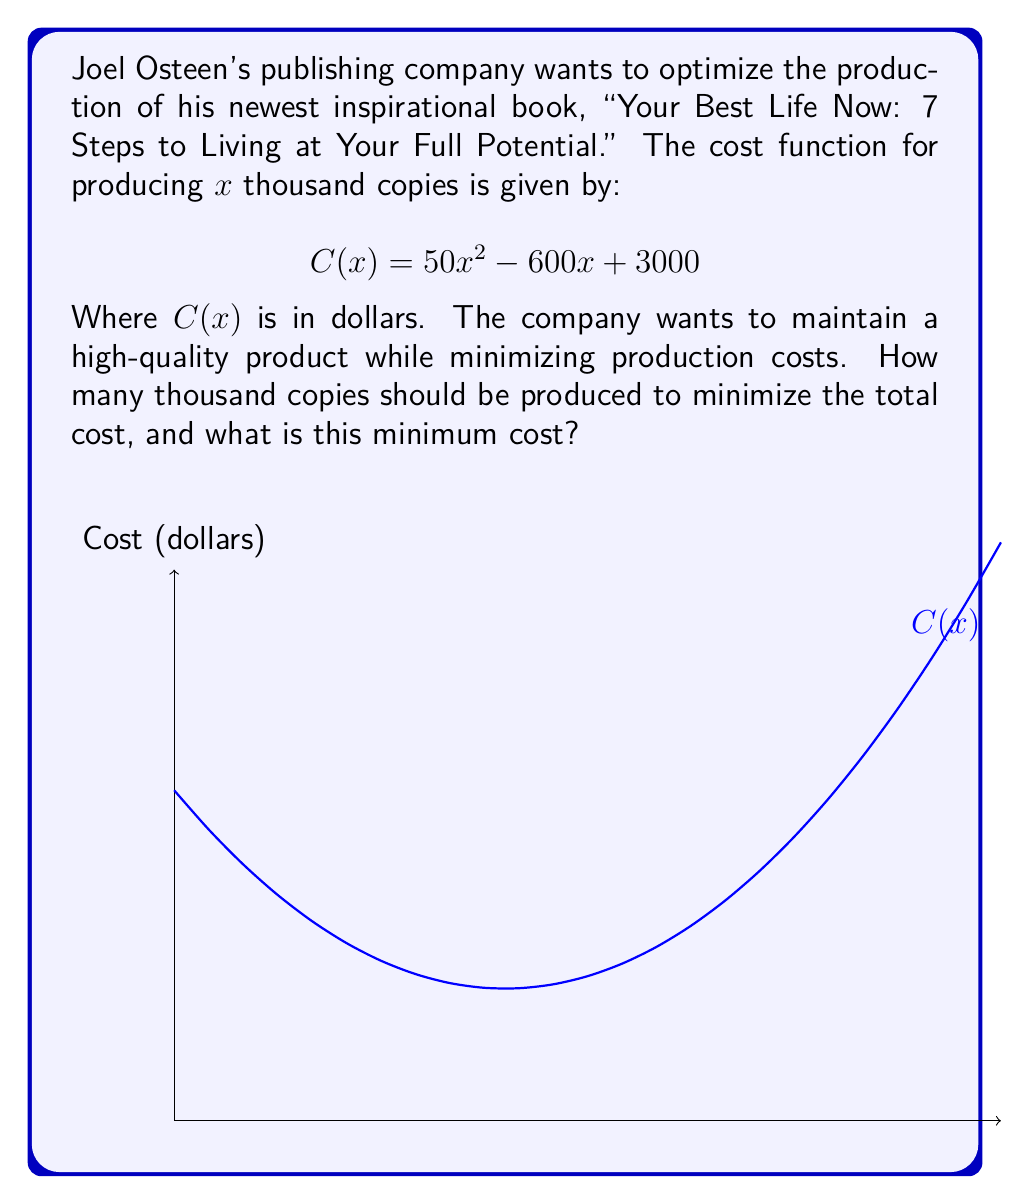Teach me how to tackle this problem. To find the minimum cost, we need to find the vertex of the parabola represented by the cost function. For a quadratic function in the form $ax^2 + bx + c$, the x-coordinate of the vertex is given by $x = -\frac{b}{2a}$.

Step 1: Identify a, b, and c in the cost function:
$C(x) = 50x^2 - 600x + 3000$
$a = 50$, $b = -600$, $c = 3000$

Step 2: Calculate the x-coordinate of the vertex:
$x = -\frac{b}{2a} = -\frac{-600}{2(50)} = \frac{600}{100} = 6$

This means the minimum cost occurs when producing 6 thousand copies.

Step 3: Calculate the minimum cost by plugging x = 6 into the original function:
$C(6) = 50(6)^2 - 600(6) + 3000$
$= 50(36) - 3600 + 3000$
$= 1800 - 3600 + 3000$
$= 1200$

Therefore, the minimum cost is $1,200.
Answer: 6 thousand copies; $1,200 